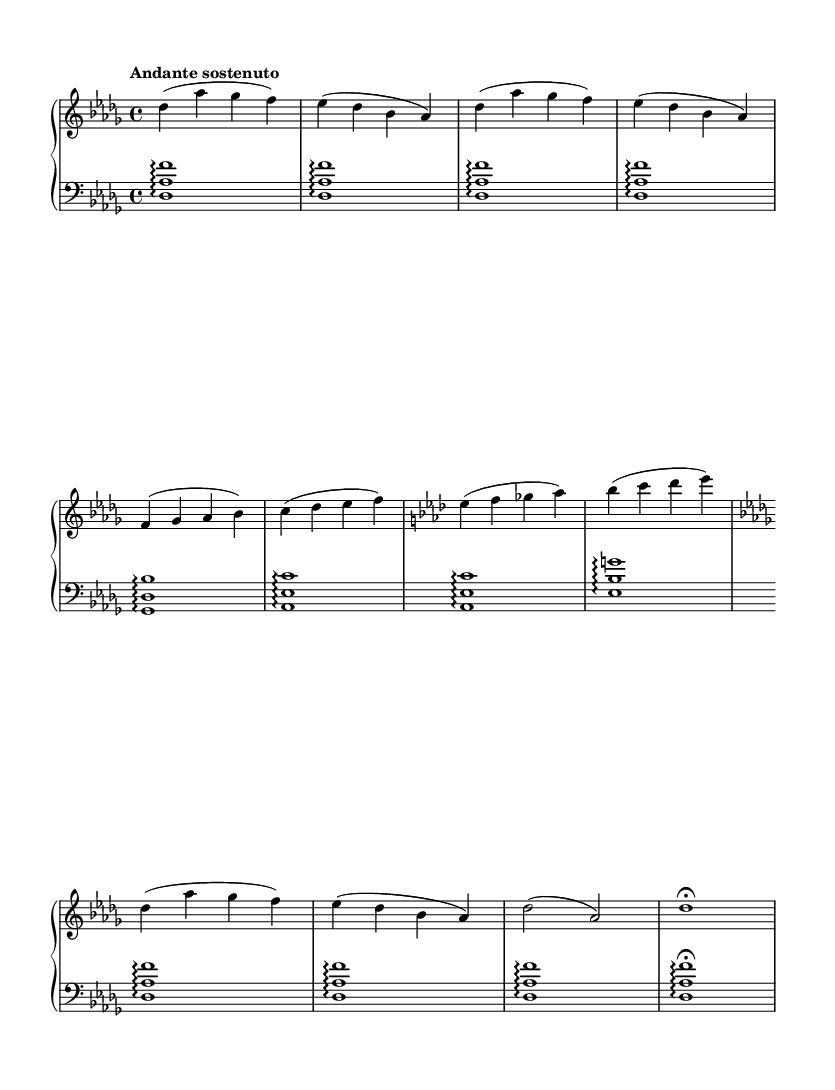What is the key signature of this music? The key signature is indicated by the sharps or flats at the beginning of the music staff. In this case, there are two flats (B♭ and E♭) present, indicating the key of D♭ major and B♭ minor.
Answer: D♭ major What is the time signature of this piece? The time signature is found at the beginning of the music, right after the key signature. It is represented by the two numbers stacked vertically. In this sheet music, the numbers are 4 and 4, indicating there are four beats per measure with a quarter note getting one beat.
Answer: 4/4 What tempo marking is specified in the score? The tempo marking, which provides performance speed guidance, is located below the clef. In this case, it is labeled as "Andante sostenuto," suggesting a moderate pace with a sustained feel.
Answer: Andante sostenuto How many sections are present in the A-B-A' structure of the piece? By analyzing the sections labeled in the music, we identify the A section, the B section, and a modified version of the A section (A'). This structure suggests three distinct sections overall.
Answer: 3 What is the pattern of arpeggiated chords in the lower staff during the introduction? The lower staff illustrates the arpeggiated chords starting with D♭, A♭, and F. Each of these chords is played as a broken chord. Observing the first measures shows a persistent A♭ major harmony utilized in an arpeggiated style.
Answer: D♭, A♭, F What key does the B section modulate to? In the B section, a change indicates a modulation to E♭ major, which is supported by the presence of notes such as E♭, F, and G. The B section's new key becomes obvious as it departs from the initial D♭ major tonality.
Answer: E♭ major How does the coda conclude the piece? The coda typically summarizes or concludes a piece. In this score, the coda features a final measure returning to the opening key signature of D♭ major, culminating with a fermata indicating a prolonged final note for emphasis.
Answer: Fermata on D♭ 